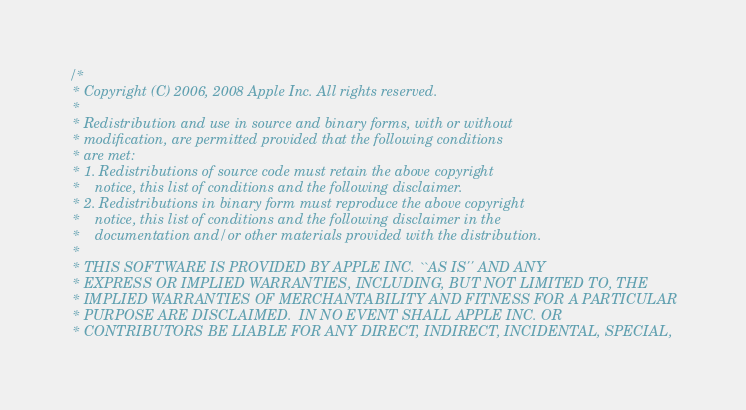Convert code to text. <code><loc_0><loc_0><loc_500><loc_500><_ObjectiveC_>/*
 * Copyright (C) 2006, 2008 Apple Inc. All rights reserved.
 *
 * Redistribution and use in source and binary forms, with or without
 * modification, are permitted provided that the following conditions
 * are met:
 * 1. Redistributions of source code must retain the above copyright
 *    notice, this list of conditions and the following disclaimer.
 * 2. Redistributions in binary form must reproduce the above copyright
 *    notice, this list of conditions and the following disclaimer in the
 *    documentation and/or other materials provided with the distribution.
 *
 * THIS SOFTWARE IS PROVIDED BY APPLE INC. ``AS IS'' AND ANY
 * EXPRESS OR IMPLIED WARRANTIES, INCLUDING, BUT NOT LIMITED TO, THE
 * IMPLIED WARRANTIES OF MERCHANTABILITY AND FITNESS FOR A PARTICULAR
 * PURPOSE ARE DISCLAIMED.  IN NO EVENT SHALL APPLE INC. OR
 * CONTRIBUTORS BE LIABLE FOR ANY DIRECT, INDIRECT, INCIDENTAL, SPECIAL,</code> 